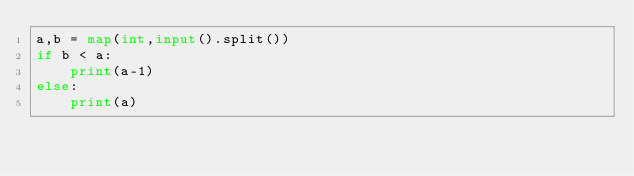<code> <loc_0><loc_0><loc_500><loc_500><_Python_>a,b = map(int,input().split())
if b < a:
    print(a-1)
else:
    print(a)</code> 